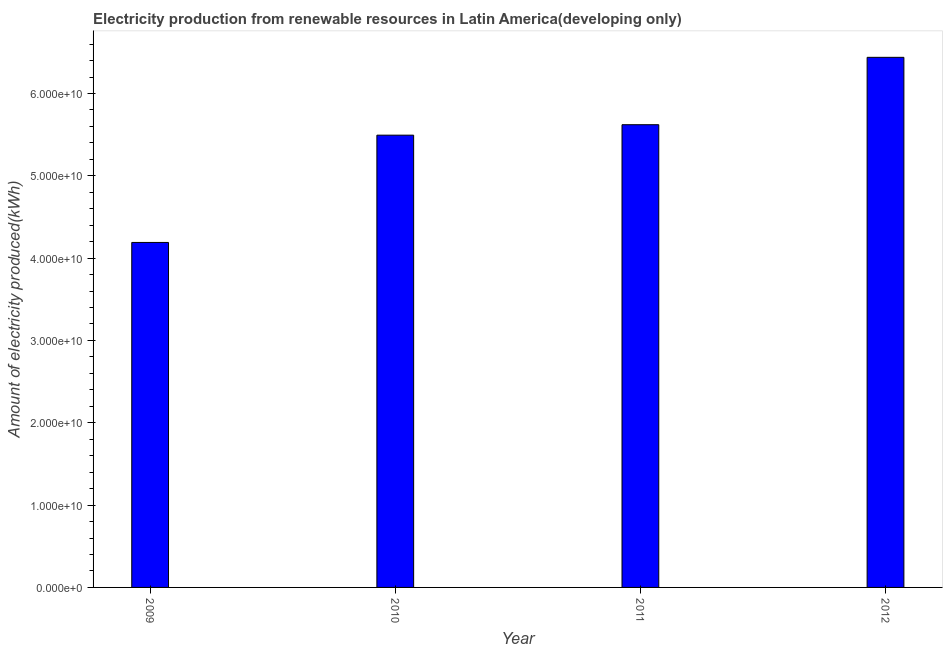Does the graph contain grids?
Make the answer very short. No. What is the title of the graph?
Give a very brief answer. Electricity production from renewable resources in Latin America(developing only). What is the label or title of the X-axis?
Your answer should be compact. Year. What is the label or title of the Y-axis?
Keep it short and to the point. Amount of electricity produced(kWh). What is the amount of electricity produced in 2012?
Your response must be concise. 6.44e+1. Across all years, what is the maximum amount of electricity produced?
Offer a terse response. 6.44e+1. Across all years, what is the minimum amount of electricity produced?
Offer a very short reply. 4.19e+1. In which year was the amount of electricity produced maximum?
Ensure brevity in your answer.  2012. In which year was the amount of electricity produced minimum?
Make the answer very short. 2009. What is the sum of the amount of electricity produced?
Provide a succinct answer. 2.17e+11. What is the difference between the amount of electricity produced in 2009 and 2012?
Provide a succinct answer. -2.25e+1. What is the average amount of electricity produced per year?
Offer a very short reply. 5.44e+1. What is the median amount of electricity produced?
Provide a succinct answer. 5.56e+1. Do a majority of the years between 2009 and 2010 (inclusive) have amount of electricity produced greater than 36000000000 kWh?
Provide a succinct answer. Yes. What is the ratio of the amount of electricity produced in 2009 to that in 2010?
Provide a short and direct response. 0.76. Is the difference between the amount of electricity produced in 2009 and 2011 greater than the difference between any two years?
Make the answer very short. No. What is the difference between the highest and the second highest amount of electricity produced?
Your answer should be very brief. 8.18e+09. What is the difference between the highest and the lowest amount of electricity produced?
Provide a short and direct response. 2.25e+1. How many bars are there?
Offer a terse response. 4. Are all the bars in the graph horizontal?
Make the answer very short. No. How many years are there in the graph?
Make the answer very short. 4. What is the difference between two consecutive major ticks on the Y-axis?
Give a very brief answer. 1.00e+1. Are the values on the major ticks of Y-axis written in scientific E-notation?
Your answer should be compact. Yes. What is the Amount of electricity produced(kWh) in 2009?
Your response must be concise. 4.19e+1. What is the Amount of electricity produced(kWh) in 2010?
Give a very brief answer. 5.49e+1. What is the Amount of electricity produced(kWh) in 2011?
Provide a succinct answer. 5.62e+1. What is the Amount of electricity produced(kWh) in 2012?
Provide a short and direct response. 6.44e+1. What is the difference between the Amount of electricity produced(kWh) in 2009 and 2010?
Your answer should be very brief. -1.30e+1. What is the difference between the Amount of electricity produced(kWh) in 2009 and 2011?
Your response must be concise. -1.43e+1. What is the difference between the Amount of electricity produced(kWh) in 2009 and 2012?
Offer a very short reply. -2.25e+1. What is the difference between the Amount of electricity produced(kWh) in 2010 and 2011?
Your answer should be very brief. -1.27e+09. What is the difference between the Amount of electricity produced(kWh) in 2010 and 2012?
Offer a terse response. -9.46e+09. What is the difference between the Amount of electricity produced(kWh) in 2011 and 2012?
Your answer should be very brief. -8.18e+09. What is the ratio of the Amount of electricity produced(kWh) in 2009 to that in 2010?
Ensure brevity in your answer.  0.76. What is the ratio of the Amount of electricity produced(kWh) in 2009 to that in 2011?
Offer a very short reply. 0.75. What is the ratio of the Amount of electricity produced(kWh) in 2009 to that in 2012?
Your response must be concise. 0.65. What is the ratio of the Amount of electricity produced(kWh) in 2010 to that in 2011?
Ensure brevity in your answer.  0.98. What is the ratio of the Amount of electricity produced(kWh) in 2010 to that in 2012?
Provide a succinct answer. 0.85. What is the ratio of the Amount of electricity produced(kWh) in 2011 to that in 2012?
Your response must be concise. 0.87. 